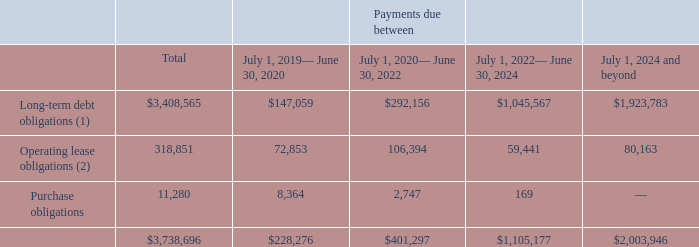Commitments and Contractual Obligations
As of June 30, 2019, we have entered into the following contractual obligations with minimum payments for the indicated fiscal periods as follows:
1) Includes interest up to maturity and principal payments. Please see note 10 "Long-Term Debt" for more details.
(2) Net of $30.7 million of sublease income to be received from properties which we have subleased to third parties.
What does the table show? Contractual obligations with minimum payments for the indicated fiscal periods. For Operating lease obligations, what is the Net of value for sublease income to be received from properties which have been subleased to third parties? $30.7 million. What is the Total Commitments and Contractual Obligations?
Answer scale should be: thousand. 3,738,696. What is the average annual fiscal year Long-term debt obligations for fiscal year 2020 to 2024?
Answer scale should be: thousand. (147,059+292,156+1,045,567)/5
Answer: 296956.4. What is the Total obligations of July 1, 2024 and beyond expressed as a percentage of Total obligations?
Answer scale should be: percent. 2,003,946/3,738,696
Answer: 53.6. For July 1, 2024 and beyond, what is Long-term debt obligations expressed as a percentage of Total obligations?
Answer scale should be: percent. 1,923,783/2,003,946
Answer: 96. 